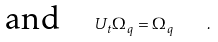Convert formula to latex. <formula><loc_0><loc_0><loc_500><loc_500>\text {and} \quad U _ { t } \Omega _ { q } = \Omega _ { q } \quad .</formula> 